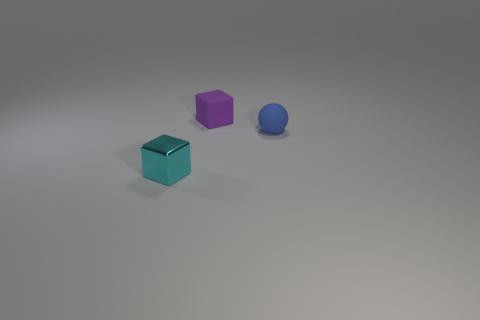Add 1 brown metallic things. How many objects exist? 4 Subtract all cubes. How many objects are left? 1 Subtract all purple cubes. Subtract all blue rubber balls. How many objects are left? 1 Add 1 blue spheres. How many blue spheres are left? 2 Add 1 tiny matte cubes. How many tiny matte cubes exist? 2 Subtract 0 blue cylinders. How many objects are left? 3 